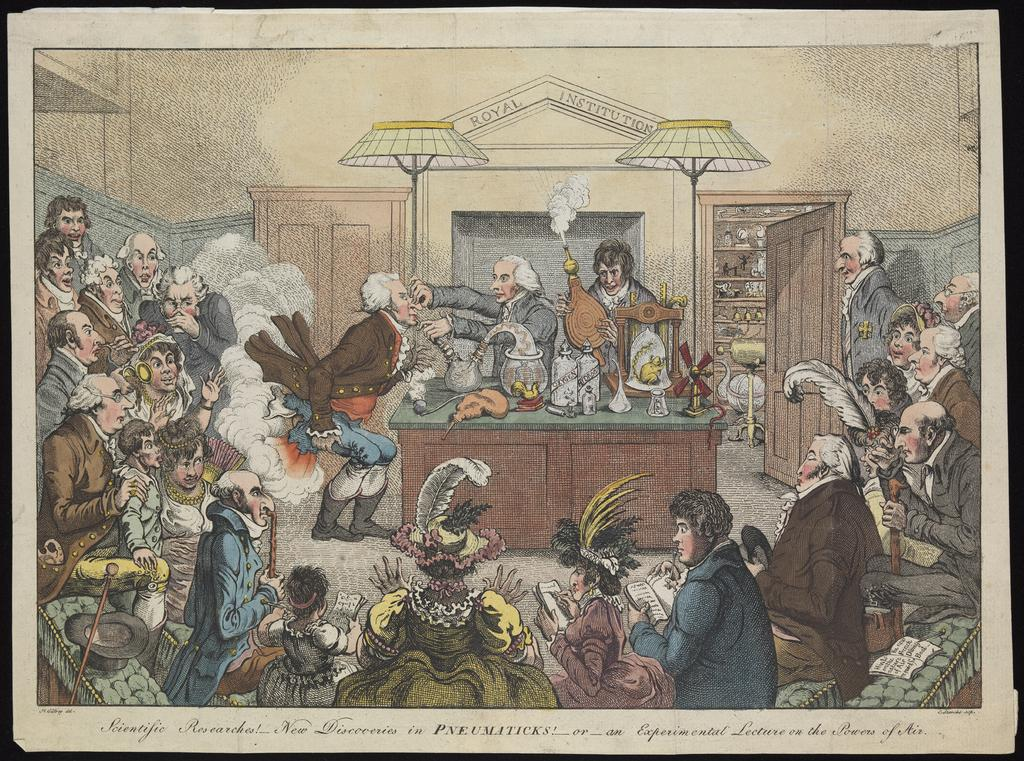<image>
Relay a brief, clear account of the picture shown. Postcard showing people performing science in a room and the words "ROYAL INSTITUTION" on the top. 